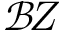Convert formula to latex. <formula><loc_0><loc_0><loc_500><loc_500>\mathcal { B } \, Z</formula> 